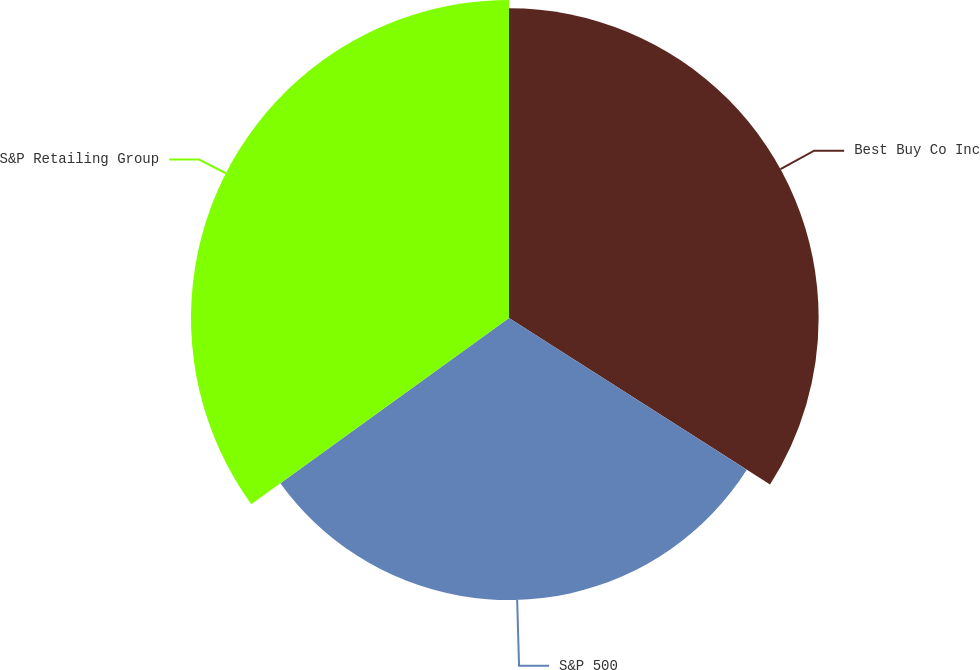Convert chart to OTSL. <chart><loc_0><loc_0><loc_500><loc_500><pie_chart><fcel>Best Buy Co Inc<fcel>S&P 500<fcel>S&P Retailing Group<nl><fcel>34.04%<fcel>31.01%<fcel>34.96%<nl></chart> 